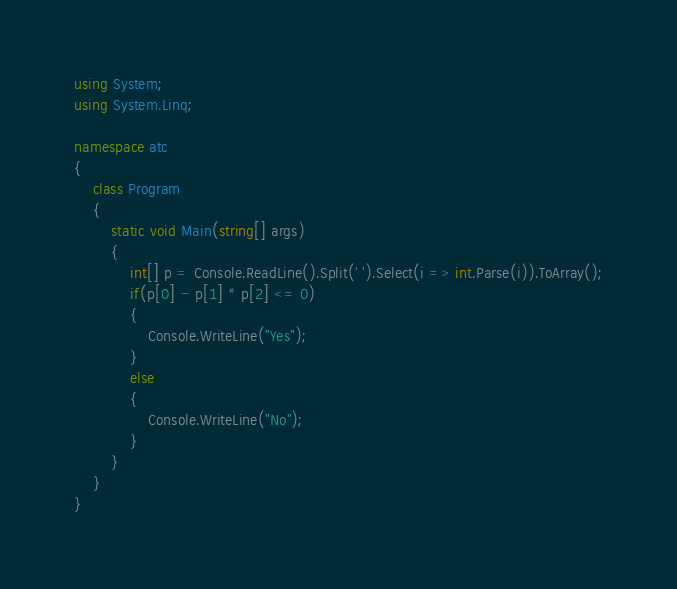Convert code to text. <code><loc_0><loc_0><loc_500><loc_500><_C#_>using System;
using System.Linq;

namespace atc
{
    class Program
    {
        static void Main(string[] args)
        {
            int[] p = Console.ReadLine().Split(' ').Select(i => int.Parse(i)).ToArray();
            if(p[0] - p[1] * p[2] <= 0)
            {
                Console.WriteLine("Yes");
            }
            else
            {
                Console.WriteLine("No");
            }
        }
    }
}
</code> 